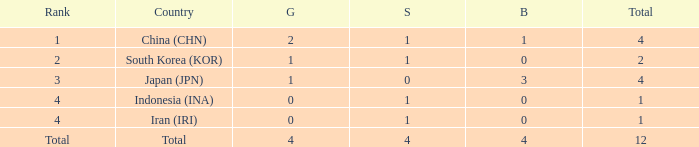How many silver medals for the nation with fewer than 1 golds and total less than 1? 0.0. 